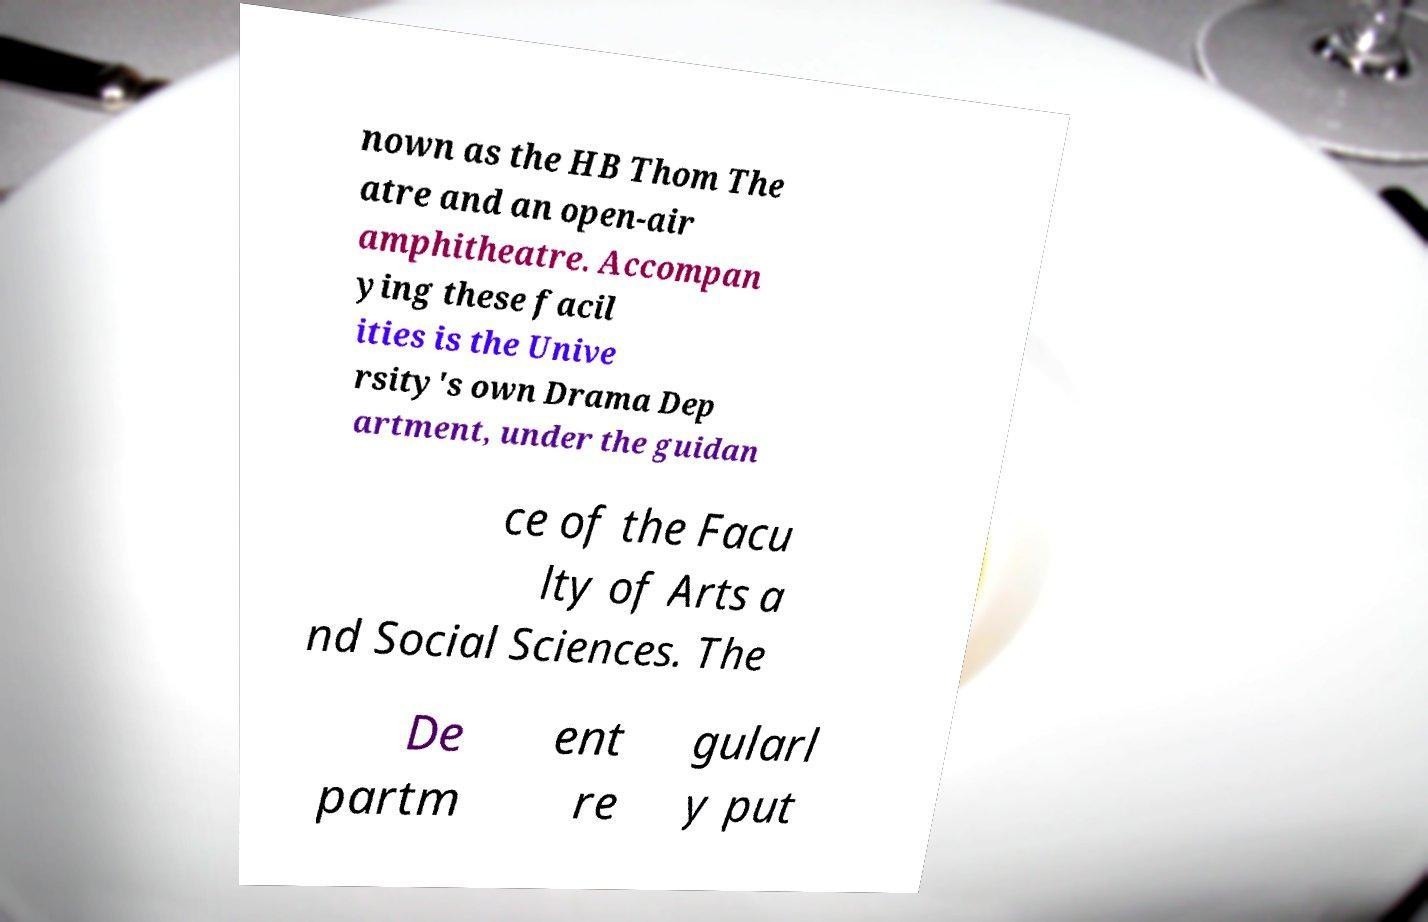Please identify and transcribe the text found in this image. nown as the HB Thom The atre and an open-air amphitheatre. Accompan ying these facil ities is the Unive rsity's own Drama Dep artment, under the guidan ce of the Facu lty of Arts a nd Social Sciences. The De partm ent re gularl y put 